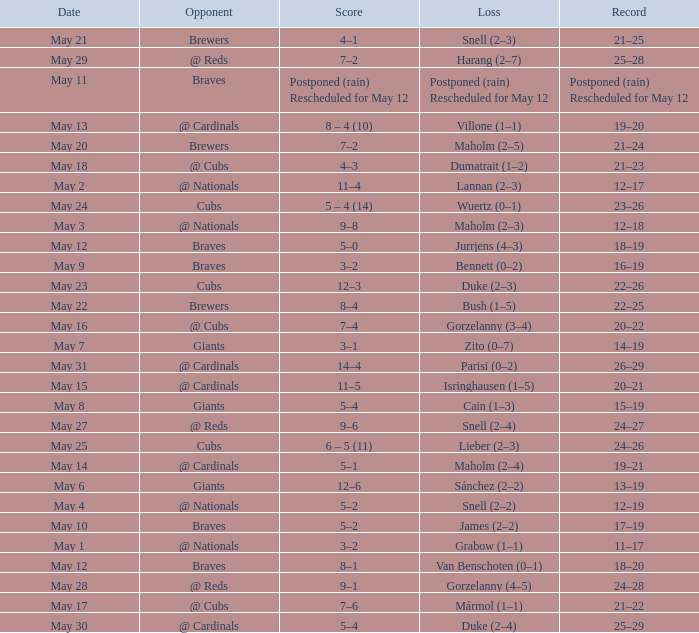What was the score of the game with a loss of Maholm (2–4)? 5–1. 